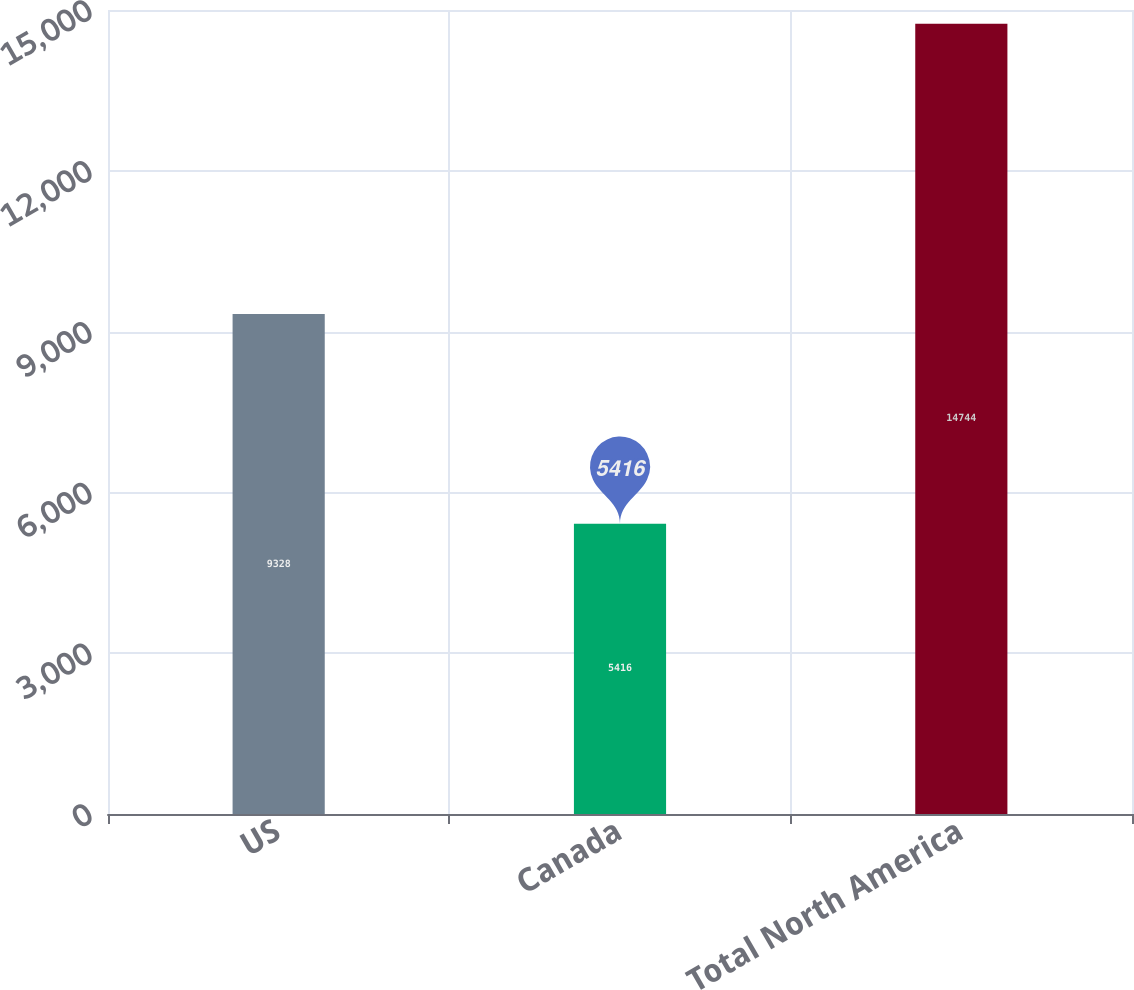Convert chart. <chart><loc_0><loc_0><loc_500><loc_500><bar_chart><fcel>US<fcel>Canada<fcel>Total North America<nl><fcel>9328<fcel>5416<fcel>14744<nl></chart> 